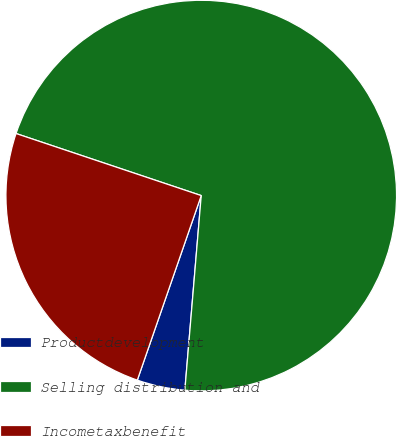Convert chart. <chart><loc_0><loc_0><loc_500><loc_500><pie_chart><fcel>Productdevelopment<fcel>Selling distribution and<fcel>Incometaxbenefit<nl><fcel>3.97%<fcel>71.19%<fcel>24.84%<nl></chart> 